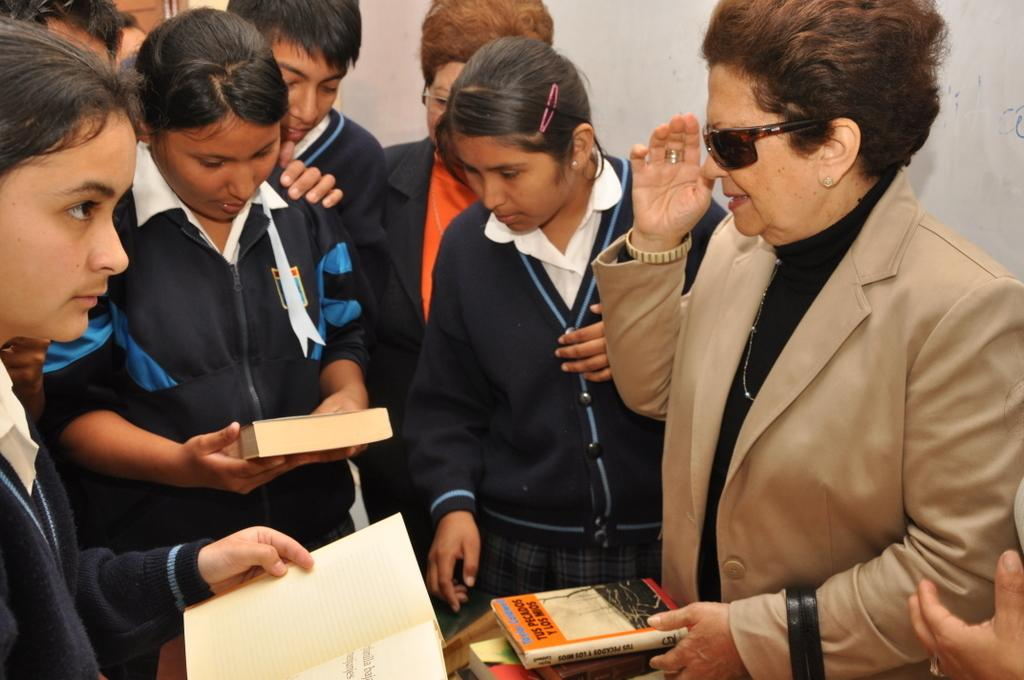How many people can be seen in the image? There are many people standing in the image. What objects are present in the image besides people? There are many books present in the image. Can you describe the girls in the image? There are two girls holding books in the image. What is the background of the image? There is a wall in the image. Where is the boundary between the two girls holding books in the image? There is no boundary between the two girls holding books in the image; they are standing close to each other. What type of balloon can be seen floating in the image? There is no balloon present in the image. 